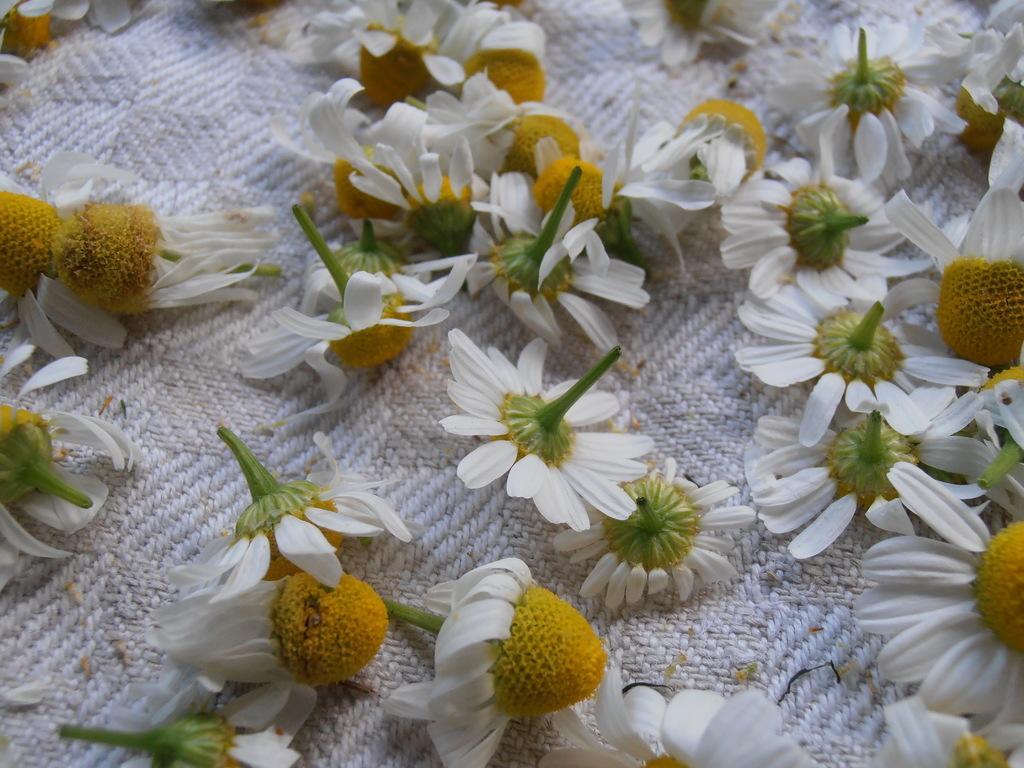Please provide a concise description of this image. In this image there are few flowers might be kept on cloth. 